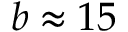Convert formula to latex. <formula><loc_0><loc_0><loc_500><loc_500>b \approx 1 5</formula> 